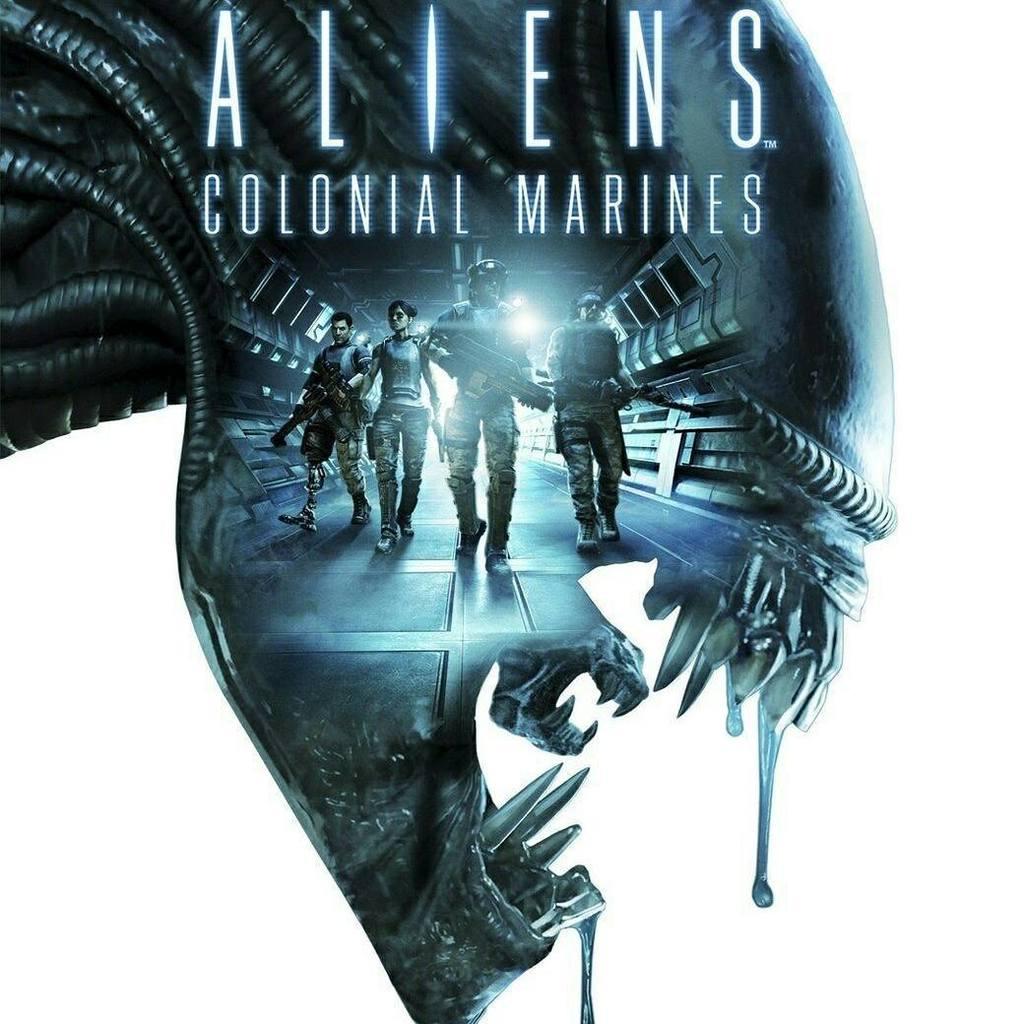What kind of marines are these?
Ensure brevity in your answer.  Colonial. 